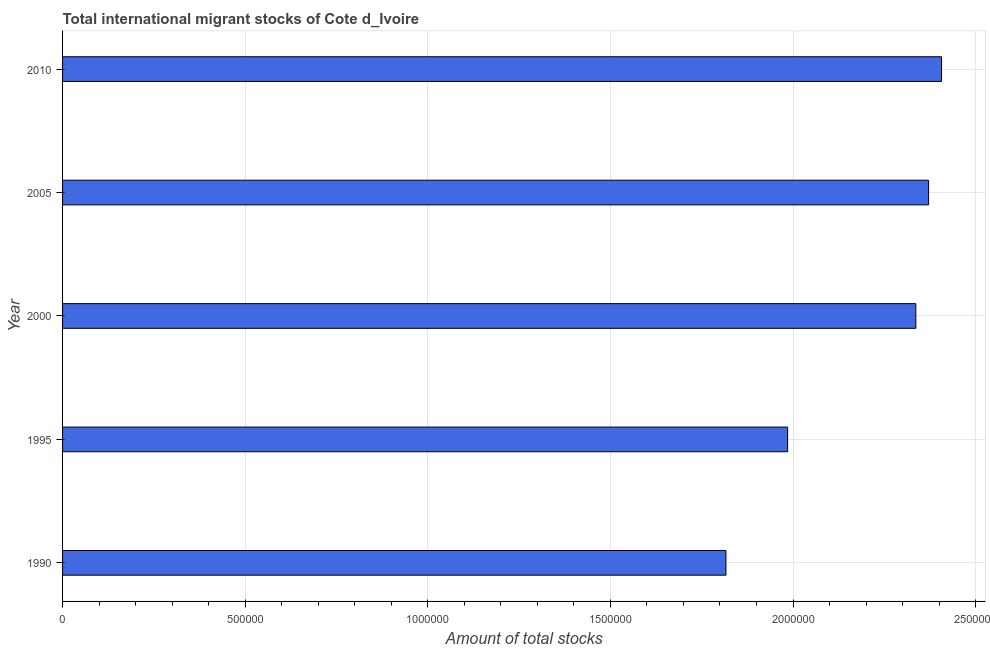What is the title of the graph?
Ensure brevity in your answer.  Total international migrant stocks of Cote d_Ivoire. What is the label or title of the X-axis?
Your response must be concise. Amount of total stocks. What is the label or title of the Y-axis?
Offer a terse response. Year. What is the total number of international migrant stock in 1990?
Ensure brevity in your answer.  1.82e+06. Across all years, what is the maximum total number of international migrant stock?
Provide a succinct answer. 2.41e+06. Across all years, what is the minimum total number of international migrant stock?
Give a very brief answer. 1.82e+06. What is the sum of the total number of international migrant stock?
Your response must be concise. 1.09e+07. What is the difference between the total number of international migrant stock in 1995 and 2000?
Keep it short and to the point. -3.51e+05. What is the average total number of international migrant stock per year?
Give a very brief answer. 2.18e+06. What is the median total number of international migrant stock?
Make the answer very short. 2.34e+06. In how many years, is the total number of international migrant stock greater than 100000 ?
Provide a short and direct response. 5. Do a majority of the years between 1995 and 2005 (inclusive) have total number of international migrant stock greater than 2300000 ?
Give a very brief answer. Yes. What is the ratio of the total number of international migrant stock in 1990 to that in 2010?
Offer a very short reply. 0.76. Is the total number of international migrant stock in 1990 less than that in 2000?
Ensure brevity in your answer.  Yes. Is the difference between the total number of international migrant stock in 2000 and 2010 greater than the difference between any two years?
Keep it short and to the point. No. What is the difference between the highest and the second highest total number of international migrant stock?
Provide a succinct answer. 3.54e+04. What is the difference between the highest and the lowest total number of international migrant stock?
Ensure brevity in your answer.  5.90e+05. In how many years, is the total number of international migrant stock greater than the average total number of international migrant stock taken over all years?
Provide a short and direct response. 3. What is the difference between two consecutive major ticks on the X-axis?
Keep it short and to the point. 5.00e+05. Are the values on the major ticks of X-axis written in scientific E-notation?
Keep it short and to the point. No. What is the Amount of total stocks in 1990?
Provide a short and direct response. 1.82e+06. What is the Amount of total stocks of 1995?
Your answer should be compact. 1.99e+06. What is the Amount of total stocks in 2000?
Offer a very short reply. 2.34e+06. What is the Amount of total stocks of 2005?
Provide a succinct answer. 2.37e+06. What is the Amount of total stocks in 2010?
Your answer should be compact. 2.41e+06. What is the difference between the Amount of total stocks in 1990 and 1995?
Your response must be concise. -1.69e+05. What is the difference between the Amount of total stocks in 1990 and 2000?
Your answer should be compact. -5.20e+05. What is the difference between the Amount of total stocks in 1990 and 2005?
Offer a terse response. -5.55e+05. What is the difference between the Amount of total stocks in 1990 and 2010?
Your response must be concise. -5.90e+05. What is the difference between the Amount of total stocks in 1995 and 2000?
Your response must be concise. -3.51e+05. What is the difference between the Amount of total stocks in 1995 and 2005?
Your answer should be compact. -3.86e+05. What is the difference between the Amount of total stocks in 1995 and 2010?
Provide a succinct answer. -4.22e+05. What is the difference between the Amount of total stocks in 2000 and 2005?
Your answer should be compact. -3.49e+04. What is the difference between the Amount of total stocks in 2000 and 2010?
Provide a short and direct response. -7.04e+04. What is the difference between the Amount of total stocks in 2005 and 2010?
Make the answer very short. -3.54e+04. What is the ratio of the Amount of total stocks in 1990 to that in 1995?
Offer a very short reply. 0.92. What is the ratio of the Amount of total stocks in 1990 to that in 2000?
Keep it short and to the point. 0.78. What is the ratio of the Amount of total stocks in 1990 to that in 2005?
Make the answer very short. 0.77. What is the ratio of the Amount of total stocks in 1990 to that in 2010?
Your response must be concise. 0.76. What is the ratio of the Amount of total stocks in 1995 to that in 2005?
Ensure brevity in your answer.  0.84. What is the ratio of the Amount of total stocks in 1995 to that in 2010?
Your answer should be compact. 0.82. What is the ratio of the Amount of total stocks in 2000 to that in 2005?
Provide a succinct answer. 0.98. What is the ratio of the Amount of total stocks in 2000 to that in 2010?
Your answer should be compact. 0.97. 